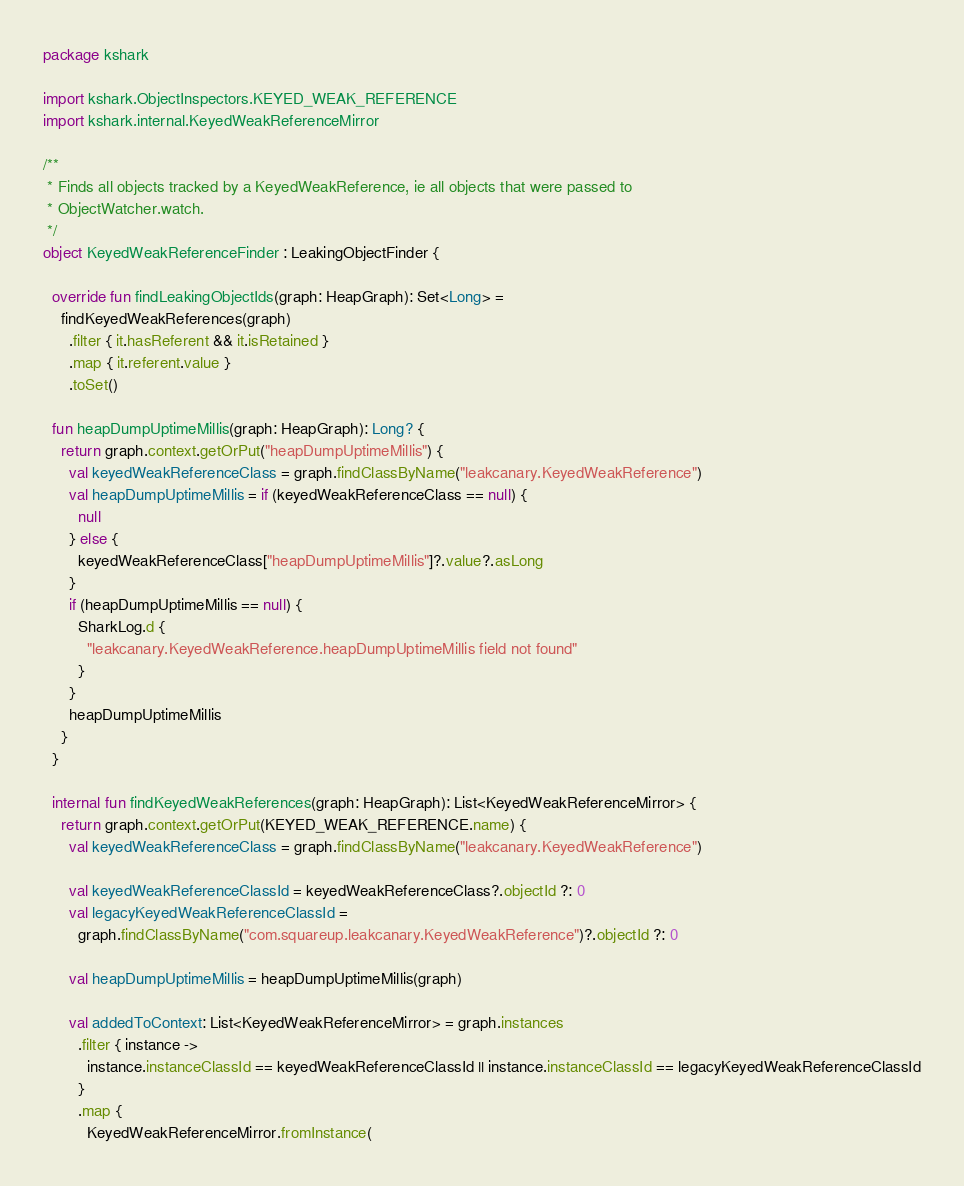Convert code to text. <code><loc_0><loc_0><loc_500><loc_500><_Kotlin_>package kshark

import kshark.ObjectInspectors.KEYED_WEAK_REFERENCE
import kshark.internal.KeyedWeakReferenceMirror

/**
 * Finds all objects tracked by a KeyedWeakReference, ie all objects that were passed to
 * ObjectWatcher.watch.
 */
object KeyedWeakReferenceFinder : LeakingObjectFinder {

  override fun findLeakingObjectIds(graph: HeapGraph): Set<Long> =
    findKeyedWeakReferences(graph)
      .filter { it.hasReferent && it.isRetained }
      .map { it.referent.value }
      .toSet()

  fun heapDumpUptimeMillis(graph: HeapGraph): Long? {
    return graph.context.getOrPut("heapDumpUptimeMillis") {
      val keyedWeakReferenceClass = graph.findClassByName("leakcanary.KeyedWeakReference")
      val heapDumpUptimeMillis = if (keyedWeakReferenceClass == null) {
        null
      } else {
        keyedWeakReferenceClass["heapDumpUptimeMillis"]?.value?.asLong
      }
      if (heapDumpUptimeMillis == null) {
        SharkLog.d {
          "leakcanary.KeyedWeakReference.heapDumpUptimeMillis field not found"
        }
      }
      heapDumpUptimeMillis
    }
  }

  internal fun findKeyedWeakReferences(graph: HeapGraph): List<KeyedWeakReferenceMirror> {
    return graph.context.getOrPut(KEYED_WEAK_REFERENCE.name) {
      val keyedWeakReferenceClass = graph.findClassByName("leakcanary.KeyedWeakReference")

      val keyedWeakReferenceClassId = keyedWeakReferenceClass?.objectId ?: 0
      val legacyKeyedWeakReferenceClassId =
        graph.findClassByName("com.squareup.leakcanary.KeyedWeakReference")?.objectId ?: 0

      val heapDumpUptimeMillis = heapDumpUptimeMillis(graph)

      val addedToContext: List<KeyedWeakReferenceMirror> = graph.instances
        .filter { instance ->
          instance.instanceClassId == keyedWeakReferenceClassId || instance.instanceClassId == legacyKeyedWeakReferenceClassId
        }
        .map {
          KeyedWeakReferenceMirror.fromInstance(</code> 